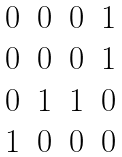<formula> <loc_0><loc_0><loc_500><loc_500>\begin{matrix} 0 & 0 & 0 & 1 \\ 0 & 0 & 0 & 1 \\ 0 & 1 & 1 & 0 \\ 1 & 0 & 0 & 0 \\ \end{matrix}</formula> 